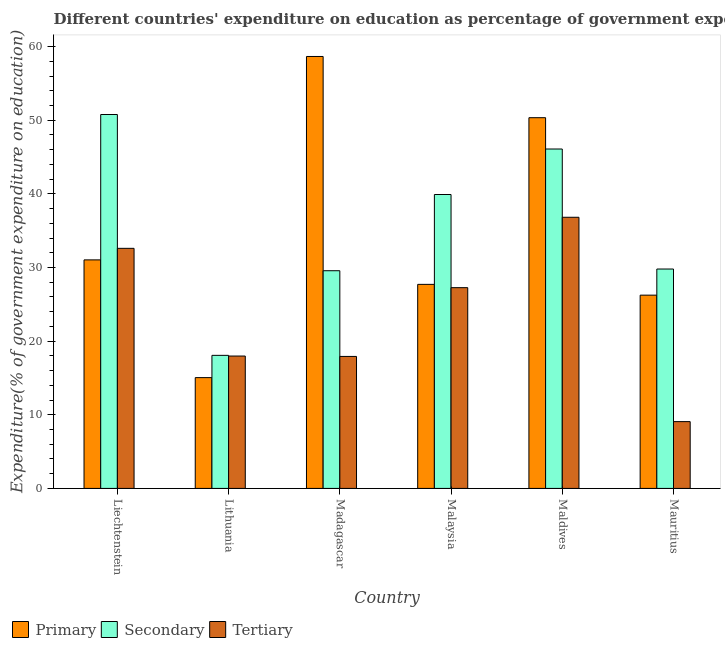Are the number of bars on each tick of the X-axis equal?
Provide a short and direct response. Yes. How many bars are there on the 1st tick from the right?
Provide a succinct answer. 3. What is the label of the 6th group of bars from the left?
Offer a very short reply. Mauritius. What is the expenditure on secondary education in Liechtenstein?
Provide a succinct answer. 50.77. Across all countries, what is the maximum expenditure on primary education?
Offer a terse response. 58.65. Across all countries, what is the minimum expenditure on tertiary education?
Your answer should be very brief. 9.07. In which country was the expenditure on primary education maximum?
Offer a terse response. Madagascar. In which country was the expenditure on secondary education minimum?
Your answer should be compact. Lithuania. What is the total expenditure on primary education in the graph?
Your response must be concise. 209.02. What is the difference between the expenditure on primary education in Madagascar and that in Mauritius?
Give a very brief answer. 32.41. What is the difference between the expenditure on tertiary education in Malaysia and the expenditure on primary education in Madagascar?
Provide a short and direct response. -31.39. What is the average expenditure on tertiary education per country?
Your answer should be compact. 23.61. What is the difference between the expenditure on tertiary education and expenditure on primary education in Mauritius?
Your answer should be compact. -17.17. What is the ratio of the expenditure on secondary education in Liechtenstein to that in Malaysia?
Offer a very short reply. 1.27. Is the difference between the expenditure on secondary education in Liechtenstein and Mauritius greater than the difference between the expenditure on tertiary education in Liechtenstein and Mauritius?
Provide a short and direct response. No. What is the difference between the highest and the second highest expenditure on tertiary education?
Offer a terse response. 4.22. What is the difference between the highest and the lowest expenditure on secondary education?
Your response must be concise. 32.7. What does the 1st bar from the left in Madagascar represents?
Provide a short and direct response. Primary. What does the 1st bar from the right in Maldives represents?
Provide a short and direct response. Tertiary. Are the values on the major ticks of Y-axis written in scientific E-notation?
Your response must be concise. No. How are the legend labels stacked?
Your answer should be very brief. Horizontal. What is the title of the graph?
Your answer should be very brief. Different countries' expenditure on education as percentage of government expenditure. What is the label or title of the X-axis?
Make the answer very short. Country. What is the label or title of the Y-axis?
Your answer should be very brief. Expenditure(% of government expenditure on education). What is the Expenditure(% of government expenditure on education) in Primary in Liechtenstein?
Make the answer very short. 31.03. What is the Expenditure(% of government expenditure on education) in Secondary in Liechtenstein?
Your response must be concise. 50.77. What is the Expenditure(% of government expenditure on education) in Tertiary in Liechtenstein?
Your answer should be compact. 32.6. What is the Expenditure(% of government expenditure on education) of Primary in Lithuania?
Offer a very short reply. 15.04. What is the Expenditure(% of government expenditure on education) in Secondary in Lithuania?
Your answer should be very brief. 18.07. What is the Expenditure(% of government expenditure on education) of Tertiary in Lithuania?
Give a very brief answer. 17.97. What is the Expenditure(% of government expenditure on education) of Primary in Madagascar?
Your answer should be very brief. 58.65. What is the Expenditure(% of government expenditure on education) in Secondary in Madagascar?
Offer a terse response. 29.56. What is the Expenditure(% of government expenditure on education) in Tertiary in Madagascar?
Provide a short and direct response. 17.92. What is the Expenditure(% of government expenditure on education) in Primary in Malaysia?
Make the answer very short. 27.71. What is the Expenditure(% of government expenditure on education) of Secondary in Malaysia?
Make the answer very short. 39.91. What is the Expenditure(% of government expenditure on education) of Tertiary in Malaysia?
Give a very brief answer. 27.26. What is the Expenditure(% of government expenditure on education) of Primary in Maldives?
Make the answer very short. 50.34. What is the Expenditure(% of government expenditure on education) in Secondary in Maldives?
Your answer should be compact. 46.09. What is the Expenditure(% of government expenditure on education) in Tertiary in Maldives?
Make the answer very short. 36.82. What is the Expenditure(% of government expenditure on education) of Primary in Mauritius?
Offer a terse response. 26.24. What is the Expenditure(% of government expenditure on education) of Secondary in Mauritius?
Ensure brevity in your answer.  29.79. What is the Expenditure(% of government expenditure on education) of Tertiary in Mauritius?
Your answer should be very brief. 9.07. Across all countries, what is the maximum Expenditure(% of government expenditure on education) in Primary?
Offer a terse response. 58.65. Across all countries, what is the maximum Expenditure(% of government expenditure on education) of Secondary?
Your answer should be very brief. 50.77. Across all countries, what is the maximum Expenditure(% of government expenditure on education) of Tertiary?
Provide a succinct answer. 36.82. Across all countries, what is the minimum Expenditure(% of government expenditure on education) in Primary?
Give a very brief answer. 15.04. Across all countries, what is the minimum Expenditure(% of government expenditure on education) of Secondary?
Ensure brevity in your answer.  18.07. Across all countries, what is the minimum Expenditure(% of government expenditure on education) in Tertiary?
Give a very brief answer. 9.07. What is the total Expenditure(% of government expenditure on education) of Primary in the graph?
Give a very brief answer. 209.02. What is the total Expenditure(% of government expenditure on education) of Secondary in the graph?
Provide a short and direct response. 214.19. What is the total Expenditure(% of government expenditure on education) in Tertiary in the graph?
Your answer should be very brief. 141.65. What is the difference between the Expenditure(% of government expenditure on education) of Primary in Liechtenstein and that in Lithuania?
Make the answer very short. 15.99. What is the difference between the Expenditure(% of government expenditure on education) in Secondary in Liechtenstein and that in Lithuania?
Offer a very short reply. 32.7. What is the difference between the Expenditure(% of government expenditure on education) of Tertiary in Liechtenstein and that in Lithuania?
Give a very brief answer. 14.63. What is the difference between the Expenditure(% of government expenditure on education) in Primary in Liechtenstein and that in Madagascar?
Provide a succinct answer. -27.62. What is the difference between the Expenditure(% of government expenditure on education) of Secondary in Liechtenstein and that in Madagascar?
Ensure brevity in your answer.  21.21. What is the difference between the Expenditure(% of government expenditure on education) of Tertiary in Liechtenstein and that in Madagascar?
Provide a short and direct response. 14.68. What is the difference between the Expenditure(% of government expenditure on education) in Primary in Liechtenstein and that in Malaysia?
Give a very brief answer. 3.32. What is the difference between the Expenditure(% of government expenditure on education) of Secondary in Liechtenstein and that in Malaysia?
Give a very brief answer. 10.86. What is the difference between the Expenditure(% of government expenditure on education) of Tertiary in Liechtenstein and that in Malaysia?
Provide a short and direct response. 5.34. What is the difference between the Expenditure(% of government expenditure on education) in Primary in Liechtenstein and that in Maldives?
Give a very brief answer. -19.31. What is the difference between the Expenditure(% of government expenditure on education) in Secondary in Liechtenstein and that in Maldives?
Give a very brief answer. 4.68. What is the difference between the Expenditure(% of government expenditure on education) in Tertiary in Liechtenstein and that in Maldives?
Your response must be concise. -4.22. What is the difference between the Expenditure(% of government expenditure on education) of Primary in Liechtenstein and that in Mauritius?
Offer a very short reply. 4.79. What is the difference between the Expenditure(% of government expenditure on education) of Secondary in Liechtenstein and that in Mauritius?
Offer a very short reply. 20.98. What is the difference between the Expenditure(% of government expenditure on education) in Tertiary in Liechtenstein and that in Mauritius?
Ensure brevity in your answer.  23.53. What is the difference between the Expenditure(% of government expenditure on education) in Primary in Lithuania and that in Madagascar?
Provide a succinct answer. -43.61. What is the difference between the Expenditure(% of government expenditure on education) in Secondary in Lithuania and that in Madagascar?
Your answer should be compact. -11.49. What is the difference between the Expenditure(% of government expenditure on education) in Tertiary in Lithuania and that in Madagascar?
Your response must be concise. 0.05. What is the difference between the Expenditure(% of government expenditure on education) in Primary in Lithuania and that in Malaysia?
Offer a very short reply. -12.66. What is the difference between the Expenditure(% of government expenditure on education) in Secondary in Lithuania and that in Malaysia?
Make the answer very short. -21.84. What is the difference between the Expenditure(% of government expenditure on education) of Tertiary in Lithuania and that in Malaysia?
Provide a short and direct response. -9.29. What is the difference between the Expenditure(% of government expenditure on education) in Primary in Lithuania and that in Maldives?
Offer a very short reply. -35.3. What is the difference between the Expenditure(% of government expenditure on education) in Secondary in Lithuania and that in Maldives?
Keep it short and to the point. -28.02. What is the difference between the Expenditure(% of government expenditure on education) in Tertiary in Lithuania and that in Maldives?
Make the answer very short. -18.84. What is the difference between the Expenditure(% of government expenditure on education) in Primary in Lithuania and that in Mauritius?
Ensure brevity in your answer.  -11.2. What is the difference between the Expenditure(% of government expenditure on education) in Secondary in Lithuania and that in Mauritius?
Your response must be concise. -11.72. What is the difference between the Expenditure(% of government expenditure on education) in Tertiary in Lithuania and that in Mauritius?
Your answer should be very brief. 8.9. What is the difference between the Expenditure(% of government expenditure on education) in Primary in Madagascar and that in Malaysia?
Your response must be concise. 30.95. What is the difference between the Expenditure(% of government expenditure on education) in Secondary in Madagascar and that in Malaysia?
Your answer should be compact. -10.35. What is the difference between the Expenditure(% of government expenditure on education) of Tertiary in Madagascar and that in Malaysia?
Keep it short and to the point. -9.34. What is the difference between the Expenditure(% of government expenditure on education) of Primary in Madagascar and that in Maldives?
Offer a very short reply. 8.31. What is the difference between the Expenditure(% of government expenditure on education) of Secondary in Madagascar and that in Maldives?
Offer a very short reply. -16.53. What is the difference between the Expenditure(% of government expenditure on education) in Tertiary in Madagascar and that in Maldives?
Ensure brevity in your answer.  -18.9. What is the difference between the Expenditure(% of government expenditure on education) in Primary in Madagascar and that in Mauritius?
Offer a terse response. 32.41. What is the difference between the Expenditure(% of government expenditure on education) of Secondary in Madagascar and that in Mauritius?
Your answer should be very brief. -0.23. What is the difference between the Expenditure(% of government expenditure on education) of Tertiary in Madagascar and that in Mauritius?
Your response must be concise. 8.85. What is the difference between the Expenditure(% of government expenditure on education) of Primary in Malaysia and that in Maldives?
Ensure brevity in your answer.  -22.63. What is the difference between the Expenditure(% of government expenditure on education) of Secondary in Malaysia and that in Maldives?
Offer a very short reply. -6.18. What is the difference between the Expenditure(% of government expenditure on education) in Tertiary in Malaysia and that in Maldives?
Give a very brief answer. -9.56. What is the difference between the Expenditure(% of government expenditure on education) of Primary in Malaysia and that in Mauritius?
Give a very brief answer. 1.46. What is the difference between the Expenditure(% of government expenditure on education) of Secondary in Malaysia and that in Mauritius?
Give a very brief answer. 10.12. What is the difference between the Expenditure(% of government expenditure on education) of Tertiary in Malaysia and that in Mauritius?
Keep it short and to the point. 18.19. What is the difference between the Expenditure(% of government expenditure on education) in Primary in Maldives and that in Mauritius?
Ensure brevity in your answer.  24.1. What is the difference between the Expenditure(% of government expenditure on education) in Secondary in Maldives and that in Mauritius?
Offer a terse response. 16.3. What is the difference between the Expenditure(% of government expenditure on education) in Tertiary in Maldives and that in Mauritius?
Offer a very short reply. 27.75. What is the difference between the Expenditure(% of government expenditure on education) in Primary in Liechtenstein and the Expenditure(% of government expenditure on education) in Secondary in Lithuania?
Your answer should be compact. 12.96. What is the difference between the Expenditure(% of government expenditure on education) of Primary in Liechtenstein and the Expenditure(% of government expenditure on education) of Tertiary in Lithuania?
Provide a succinct answer. 13.06. What is the difference between the Expenditure(% of government expenditure on education) of Secondary in Liechtenstein and the Expenditure(% of government expenditure on education) of Tertiary in Lithuania?
Your response must be concise. 32.8. What is the difference between the Expenditure(% of government expenditure on education) of Primary in Liechtenstein and the Expenditure(% of government expenditure on education) of Secondary in Madagascar?
Your answer should be very brief. 1.47. What is the difference between the Expenditure(% of government expenditure on education) of Primary in Liechtenstein and the Expenditure(% of government expenditure on education) of Tertiary in Madagascar?
Keep it short and to the point. 13.11. What is the difference between the Expenditure(% of government expenditure on education) of Secondary in Liechtenstein and the Expenditure(% of government expenditure on education) of Tertiary in Madagascar?
Make the answer very short. 32.85. What is the difference between the Expenditure(% of government expenditure on education) in Primary in Liechtenstein and the Expenditure(% of government expenditure on education) in Secondary in Malaysia?
Your answer should be compact. -8.88. What is the difference between the Expenditure(% of government expenditure on education) of Primary in Liechtenstein and the Expenditure(% of government expenditure on education) of Tertiary in Malaysia?
Offer a terse response. 3.77. What is the difference between the Expenditure(% of government expenditure on education) in Secondary in Liechtenstein and the Expenditure(% of government expenditure on education) in Tertiary in Malaysia?
Your response must be concise. 23.51. What is the difference between the Expenditure(% of government expenditure on education) in Primary in Liechtenstein and the Expenditure(% of government expenditure on education) in Secondary in Maldives?
Offer a very short reply. -15.06. What is the difference between the Expenditure(% of government expenditure on education) of Primary in Liechtenstein and the Expenditure(% of government expenditure on education) of Tertiary in Maldives?
Your answer should be very brief. -5.79. What is the difference between the Expenditure(% of government expenditure on education) of Secondary in Liechtenstein and the Expenditure(% of government expenditure on education) of Tertiary in Maldives?
Offer a terse response. 13.95. What is the difference between the Expenditure(% of government expenditure on education) of Primary in Liechtenstein and the Expenditure(% of government expenditure on education) of Secondary in Mauritius?
Provide a short and direct response. 1.24. What is the difference between the Expenditure(% of government expenditure on education) in Primary in Liechtenstein and the Expenditure(% of government expenditure on education) in Tertiary in Mauritius?
Your answer should be compact. 21.96. What is the difference between the Expenditure(% of government expenditure on education) in Secondary in Liechtenstein and the Expenditure(% of government expenditure on education) in Tertiary in Mauritius?
Your answer should be very brief. 41.7. What is the difference between the Expenditure(% of government expenditure on education) of Primary in Lithuania and the Expenditure(% of government expenditure on education) of Secondary in Madagascar?
Your response must be concise. -14.52. What is the difference between the Expenditure(% of government expenditure on education) of Primary in Lithuania and the Expenditure(% of government expenditure on education) of Tertiary in Madagascar?
Offer a very short reply. -2.88. What is the difference between the Expenditure(% of government expenditure on education) of Secondary in Lithuania and the Expenditure(% of government expenditure on education) of Tertiary in Madagascar?
Your response must be concise. 0.15. What is the difference between the Expenditure(% of government expenditure on education) in Primary in Lithuania and the Expenditure(% of government expenditure on education) in Secondary in Malaysia?
Your answer should be very brief. -24.87. What is the difference between the Expenditure(% of government expenditure on education) in Primary in Lithuania and the Expenditure(% of government expenditure on education) in Tertiary in Malaysia?
Ensure brevity in your answer.  -12.22. What is the difference between the Expenditure(% of government expenditure on education) of Secondary in Lithuania and the Expenditure(% of government expenditure on education) of Tertiary in Malaysia?
Offer a very short reply. -9.19. What is the difference between the Expenditure(% of government expenditure on education) in Primary in Lithuania and the Expenditure(% of government expenditure on education) in Secondary in Maldives?
Provide a succinct answer. -31.04. What is the difference between the Expenditure(% of government expenditure on education) of Primary in Lithuania and the Expenditure(% of government expenditure on education) of Tertiary in Maldives?
Your answer should be compact. -21.77. What is the difference between the Expenditure(% of government expenditure on education) of Secondary in Lithuania and the Expenditure(% of government expenditure on education) of Tertiary in Maldives?
Make the answer very short. -18.75. What is the difference between the Expenditure(% of government expenditure on education) in Primary in Lithuania and the Expenditure(% of government expenditure on education) in Secondary in Mauritius?
Offer a very short reply. -14.75. What is the difference between the Expenditure(% of government expenditure on education) of Primary in Lithuania and the Expenditure(% of government expenditure on education) of Tertiary in Mauritius?
Provide a succinct answer. 5.97. What is the difference between the Expenditure(% of government expenditure on education) in Secondary in Lithuania and the Expenditure(% of government expenditure on education) in Tertiary in Mauritius?
Give a very brief answer. 9. What is the difference between the Expenditure(% of government expenditure on education) in Primary in Madagascar and the Expenditure(% of government expenditure on education) in Secondary in Malaysia?
Provide a succinct answer. 18.74. What is the difference between the Expenditure(% of government expenditure on education) in Primary in Madagascar and the Expenditure(% of government expenditure on education) in Tertiary in Malaysia?
Your answer should be very brief. 31.39. What is the difference between the Expenditure(% of government expenditure on education) in Secondary in Madagascar and the Expenditure(% of government expenditure on education) in Tertiary in Malaysia?
Offer a terse response. 2.3. What is the difference between the Expenditure(% of government expenditure on education) of Primary in Madagascar and the Expenditure(% of government expenditure on education) of Secondary in Maldives?
Offer a terse response. 12.57. What is the difference between the Expenditure(% of government expenditure on education) of Primary in Madagascar and the Expenditure(% of government expenditure on education) of Tertiary in Maldives?
Provide a short and direct response. 21.84. What is the difference between the Expenditure(% of government expenditure on education) of Secondary in Madagascar and the Expenditure(% of government expenditure on education) of Tertiary in Maldives?
Your response must be concise. -7.26. What is the difference between the Expenditure(% of government expenditure on education) of Primary in Madagascar and the Expenditure(% of government expenditure on education) of Secondary in Mauritius?
Give a very brief answer. 28.86. What is the difference between the Expenditure(% of government expenditure on education) of Primary in Madagascar and the Expenditure(% of government expenditure on education) of Tertiary in Mauritius?
Give a very brief answer. 49.58. What is the difference between the Expenditure(% of government expenditure on education) of Secondary in Madagascar and the Expenditure(% of government expenditure on education) of Tertiary in Mauritius?
Provide a succinct answer. 20.49. What is the difference between the Expenditure(% of government expenditure on education) of Primary in Malaysia and the Expenditure(% of government expenditure on education) of Secondary in Maldives?
Ensure brevity in your answer.  -18.38. What is the difference between the Expenditure(% of government expenditure on education) of Primary in Malaysia and the Expenditure(% of government expenditure on education) of Tertiary in Maldives?
Provide a short and direct response. -9.11. What is the difference between the Expenditure(% of government expenditure on education) in Secondary in Malaysia and the Expenditure(% of government expenditure on education) in Tertiary in Maldives?
Your response must be concise. 3.09. What is the difference between the Expenditure(% of government expenditure on education) in Primary in Malaysia and the Expenditure(% of government expenditure on education) in Secondary in Mauritius?
Offer a terse response. -2.08. What is the difference between the Expenditure(% of government expenditure on education) in Primary in Malaysia and the Expenditure(% of government expenditure on education) in Tertiary in Mauritius?
Your answer should be compact. 18.64. What is the difference between the Expenditure(% of government expenditure on education) of Secondary in Malaysia and the Expenditure(% of government expenditure on education) of Tertiary in Mauritius?
Keep it short and to the point. 30.84. What is the difference between the Expenditure(% of government expenditure on education) in Primary in Maldives and the Expenditure(% of government expenditure on education) in Secondary in Mauritius?
Provide a succinct answer. 20.55. What is the difference between the Expenditure(% of government expenditure on education) of Primary in Maldives and the Expenditure(% of government expenditure on education) of Tertiary in Mauritius?
Your answer should be compact. 41.27. What is the difference between the Expenditure(% of government expenditure on education) in Secondary in Maldives and the Expenditure(% of government expenditure on education) in Tertiary in Mauritius?
Give a very brief answer. 37.02. What is the average Expenditure(% of government expenditure on education) in Primary per country?
Make the answer very short. 34.84. What is the average Expenditure(% of government expenditure on education) in Secondary per country?
Offer a very short reply. 35.7. What is the average Expenditure(% of government expenditure on education) in Tertiary per country?
Your response must be concise. 23.61. What is the difference between the Expenditure(% of government expenditure on education) in Primary and Expenditure(% of government expenditure on education) in Secondary in Liechtenstein?
Make the answer very short. -19.74. What is the difference between the Expenditure(% of government expenditure on education) of Primary and Expenditure(% of government expenditure on education) of Tertiary in Liechtenstein?
Your answer should be compact. -1.57. What is the difference between the Expenditure(% of government expenditure on education) of Secondary and Expenditure(% of government expenditure on education) of Tertiary in Liechtenstein?
Give a very brief answer. 18.17. What is the difference between the Expenditure(% of government expenditure on education) in Primary and Expenditure(% of government expenditure on education) in Secondary in Lithuania?
Keep it short and to the point. -3.02. What is the difference between the Expenditure(% of government expenditure on education) of Primary and Expenditure(% of government expenditure on education) of Tertiary in Lithuania?
Offer a very short reply. -2.93. What is the difference between the Expenditure(% of government expenditure on education) of Secondary and Expenditure(% of government expenditure on education) of Tertiary in Lithuania?
Provide a short and direct response. 0.09. What is the difference between the Expenditure(% of government expenditure on education) of Primary and Expenditure(% of government expenditure on education) of Secondary in Madagascar?
Your answer should be very brief. 29.09. What is the difference between the Expenditure(% of government expenditure on education) in Primary and Expenditure(% of government expenditure on education) in Tertiary in Madagascar?
Provide a short and direct response. 40.73. What is the difference between the Expenditure(% of government expenditure on education) in Secondary and Expenditure(% of government expenditure on education) in Tertiary in Madagascar?
Your answer should be very brief. 11.64. What is the difference between the Expenditure(% of government expenditure on education) of Primary and Expenditure(% of government expenditure on education) of Secondary in Malaysia?
Your response must be concise. -12.2. What is the difference between the Expenditure(% of government expenditure on education) in Primary and Expenditure(% of government expenditure on education) in Tertiary in Malaysia?
Give a very brief answer. 0.45. What is the difference between the Expenditure(% of government expenditure on education) in Secondary and Expenditure(% of government expenditure on education) in Tertiary in Malaysia?
Your answer should be compact. 12.65. What is the difference between the Expenditure(% of government expenditure on education) of Primary and Expenditure(% of government expenditure on education) of Secondary in Maldives?
Offer a terse response. 4.25. What is the difference between the Expenditure(% of government expenditure on education) in Primary and Expenditure(% of government expenditure on education) in Tertiary in Maldives?
Your response must be concise. 13.52. What is the difference between the Expenditure(% of government expenditure on education) in Secondary and Expenditure(% of government expenditure on education) in Tertiary in Maldives?
Offer a terse response. 9.27. What is the difference between the Expenditure(% of government expenditure on education) of Primary and Expenditure(% of government expenditure on education) of Secondary in Mauritius?
Provide a short and direct response. -3.55. What is the difference between the Expenditure(% of government expenditure on education) in Primary and Expenditure(% of government expenditure on education) in Tertiary in Mauritius?
Your answer should be compact. 17.17. What is the difference between the Expenditure(% of government expenditure on education) in Secondary and Expenditure(% of government expenditure on education) in Tertiary in Mauritius?
Your response must be concise. 20.72. What is the ratio of the Expenditure(% of government expenditure on education) in Primary in Liechtenstein to that in Lithuania?
Offer a very short reply. 2.06. What is the ratio of the Expenditure(% of government expenditure on education) of Secondary in Liechtenstein to that in Lithuania?
Offer a very short reply. 2.81. What is the ratio of the Expenditure(% of government expenditure on education) of Tertiary in Liechtenstein to that in Lithuania?
Provide a short and direct response. 1.81. What is the ratio of the Expenditure(% of government expenditure on education) of Primary in Liechtenstein to that in Madagascar?
Your answer should be compact. 0.53. What is the ratio of the Expenditure(% of government expenditure on education) of Secondary in Liechtenstein to that in Madagascar?
Keep it short and to the point. 1.72. What is the ratio of the Expenditure(% of government expenditure on education) of Tertiary in Liechtenstein to that in Madagascar?
Offer a terse response. 1.82. What is the ratio of the Expenditure(% of government expenditure on education) in Primary in Liechtenstein to that in Malaysia?
Your answer should be very brief. 1.12. What is the ratio of the Expenditure(% of government expenditure on education) of Secondary in Liechtenstein to that in Malaysia?
Offer a terse response. 1.27. What is the ratio of the Expenditure(% of government expenditure on education) in Tertiary in Liechtenstein to that in Malaysia?
Your response must be concise. 1.2. What is the ratio of the Expenditure(% of government expenditure on education) of Primary in Liechtenstein to that in Maldives?
Provide a succinct answer. 0.62. What is the ratio of the Expenditure(% of government expenditure on education) in Secondary in Liechtenstein to that in Maldives?
Provide a succinct answer. 1.1. What is the ratio of the Expenditure(% of government expenditure on education) in Tertiary in Liechtenstein to that in Maldives?
Provide a short and direct response. 0.89. What is the ratio of the Expenditure(% of government expenditure on education) of Primary in Liechtenstein to that in Mauritius?
Keep it short and to the point. 1.18. What is the ratio of the Expenditure(% of government expenditure on education) in Secondary in Liechtenstein to that in Mauritius?
Provide a short and direct response. 1.7. What is the ratio of the Expenditure(% of government expenditure on education) of Tertiary in Liechtenstein to that in Mauritius?
Ensure brevity in your answer.  3.59. What is the ratio of the Expenditure(% of government expenditure on education) in Primary in Lithuania to that in Madagascar?
Make the answer very short. 0.26. What is the ratio of the Expenditure(% of government expenditure on education) in Secondary in Lithuania to that in Madagascar?
Offer a very short reply. 0.61. What is the ratio of the Expenditure(% of government expenditure on education) of Tertiary in Lithuania to that in Madagascar?
Your answer should be compact. 1. What is the ratio of the Expenditure(% of government expenditure on education) of Primary in Lithuania to that in Malaysia?
Your answer should be very brief. 0.54. What is the ratio of the Expenditure(% of government expenditure on education) of Secondary in Lithuania to that in Malaysia?
Your answer should be very brief. 0.45. What is the ratio of the Expenditure(% of government expenditure on education) in Tertiary in Lithuania to that in Malaysia?
Keep it short and to the point. 0.66. What is the ratio of the Expenditure(% of government expenditure on education) in Primary in Lithuania to that in Maldives?
Your answer should be compact. 0.3. What is the ratio of the Expenditure(% of government expenditure on education) of Secondary in Lithuania to that in Maldives?
Offer a terse response. 0.39. What is the ratio of the Expenditure(% of government expenditure on education) in Tertiary in Lithuania to that in Maldives?
Provide a short and direct response. 0.49. What is the ratio of the Expenditure(% of government expenditure on education) of Primary in Lithuania to that in Mauritius?
Offer a very short reply. 0.57. What is the ratio of the Expenditure(% of government expenditure on education) of Secondary in Lithuania to that in Mauritius?
Make the answer very short. 0.61. What is the ratio of the Expenditure(% of government expenditure on education) in Tertiary in Lithuania to that in Mauritius?
Give a very brief answer. 1.98. What is the ratio of the Expenditure(% of government expenditure on education) in Primary in Madagascar to that in Malaysia?
Your answer should be very brief. 2.12. What is the ratio of the Expenditure(% of government expenditure on education) of Secondary in Madagascar to that in Malaysia?
Offer a very short reply. 0.74. What is the ratio of the Expenditure(% of government expenditure on education) of Tertiary in Madagascar to that in Malaysia?
Offer a terse response. 0.66. What is the ratio of the Expenditure(% of government expenditure on education) of Primary in Madagascar to that in Maldives?
Your answer should be very brief. 1.17. What is the ratio of the Expenditure(% of government expenditure on education) of Secondary in Madagascar to that in Maldives?
Provide a succinct answer. 0.64. What is the ratio of the Expenditure(% of government expenditure on education) of Tertiary in Madagascar to that in Maldives?
Make the answer very short. 0.49. What is the ratio of the Expenditure(% of government expenditure on education) in Primary in Madagascar to that in Mauritius?
Ensure brevity in your answer.  2.23. What is the ratio of the Expenditure(% of government expenditure on education) of Tertiary in Madagascar to that in Mauritius?
Offer a terse response. 1.98. What is the ratio of the Expenditure(% of government expenditure on education) in Primary in Malaysia to that in Maldives?
Provide a succinct answer. 0.55. What is the ratio of the Expenditure(% of government expenditure on education) of Secondary in Malaysia to that in Maldives?
Provide a short and direct response. 0.87. What is the ratio of the Expenditure(% of government expenditure on education) of Tertiary in Malaysia to that in Maldives?
Offer a terse response. 0.74. What is the ratio of the Expenditure(% of government expenditure on education) of Primary in Malaysia to that in Mauritius?
Provide a short and direct response. 1.06. What is the ratio of the Expenditure(% of government expenditure on education) of Secondary in Malaysia to that in Mauritius?
Provide a succinct answer. 1.34. What is the ratio of the Expenditure(% of government expenditure on education) in Tertiary in Malaysia to that in Mauritius?
Offer a very short reply. 3.01. What is the ratio of the Expenditure(% of government expenditure on education) of Primary in Maldives to that in Mauritius?
Ensure brevity in your answer.  1.92. What is the ratio of the Expenditure(% of government expenditure on education) of Secondary in Maldives to that in Mauritius?
Offer a very short reply. 1.55. What is the ratio of the Expenditure(% of government expenditure on education) in Tertiary in Maldives to that in Mauritius?
Provide a short and direct response. 4.06. What is the difference between the highest and the second highest Expenditure(% of government expenditure on education) of Primary?
Give a very brief answer. 8.31. What is the difference between the highest and the second highest Expenditure(% of government expenditure on education) in Secondary?
Make the answer very short. 4.68. What is the difference between the highest and the second highest Expenditure(% of government expenditure on education) of Tertiary?
Keep it short and to the point. 4.22. What is the difference between the highest and the lowest Expenditure(% of government expenditure on education) in Primary?
Your answer should be very brief. 43.61. What is the difference between the highest and the lowest Expenditure(% of government expenditure on education) in Secondary?
Offer a very short reply. 32.7. What is the difference between the highest and the lowest Expenditure(% of government expenditure on education) of Tertiary?
Provide a short and direct response. 27.75. 